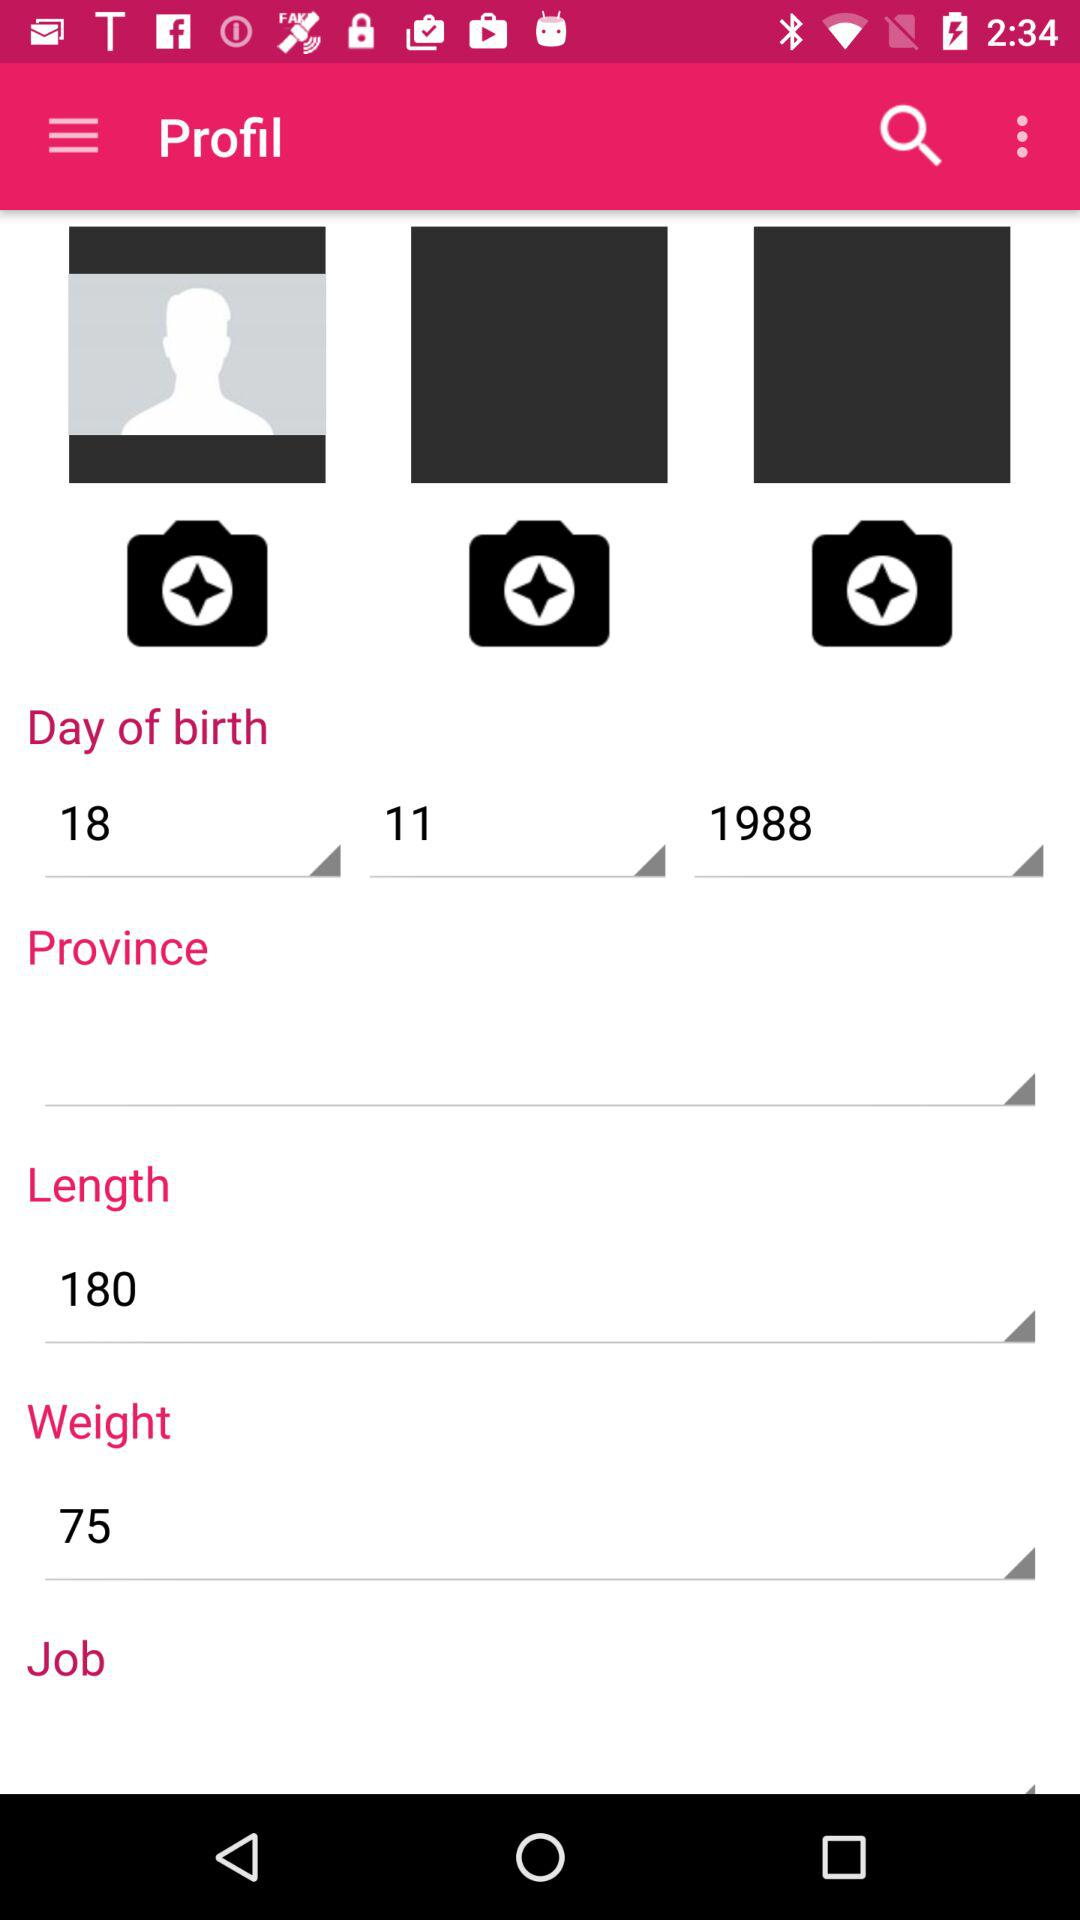What is the length of the user? The length of the user is 180. 